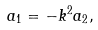Convert formula to latex. <formula><loc_0><loc_0><loc_500><loc_500>a _ { 1 } = - k ^ { 2 } a _ { 2 } ,</formula> 